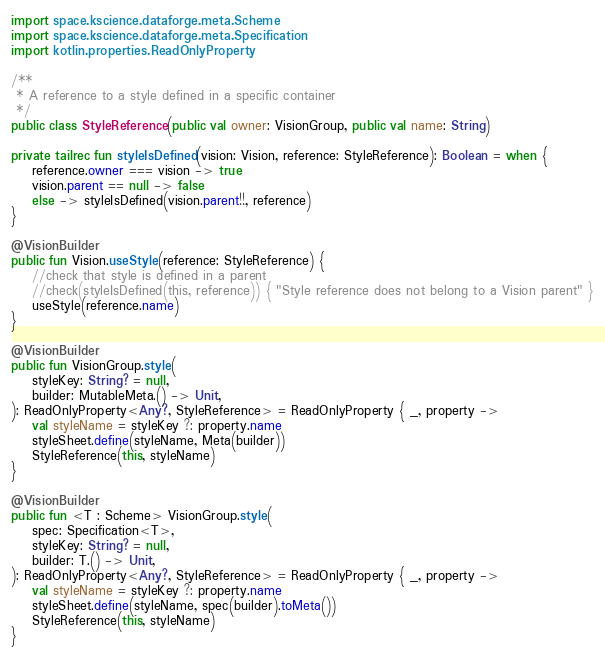<code> <loc_0><loc_0><loc_500><loc_500><_Kotlin_>import space.kscience.dataforge.meta.Scheme
import space.kscience.dataforge.meta.Specification
import kotlin.properties.ReadOnlyProperty

/**
 * A reference to a style defined in a specific container
 */
public class StyleReference(public val owner: VisionGroup, public val name: String)

private tailrec fun styleIsDefined(vision: Vision, reference: StyleReference): Boolean = when {
    reference.owner === vision -> true
    vision.parent == null -> false
    else -> styleIsDefined(vision.parent!!, reference)
}

@VisionBuilder
public fun Vision.useStyle(reference: StyleReference) {
    //check that style is defined in a parent
    //check(styleIsDefined(this, reference)) { "Style reference does not belong to a Vision parent" }
    useStyle(reference.name)
}

@VisionBuilder
public fun VisionGroup.style(
    styleKey: String? = null,
    builder: MutableMeta.() -> Unit,
): ReadOnlyProperty<Any?, StyleReference> = ReadOnlyProperty { _, property ->
    val styleName = styleKey ?: property.name
    styleSheet.define(styleName, Meta(builder))
    StyleReference(this, styleName)
}

@VisionBuilder
public fun <T : Scheme> VisionGroup.style(
    spec: Specification<T>,
    styleKey: String? = null,
    builder: T.() -> Unit,
): ReadOnlyProperty<Any?, StyleReference> = ReadOnlyProperty { _, property ->
    val styleName = styleKey ?: property.name
    styleSheet.define(styleName, spec(builder).toMeta())
    StyleReference(this, styleName)
}</code> 